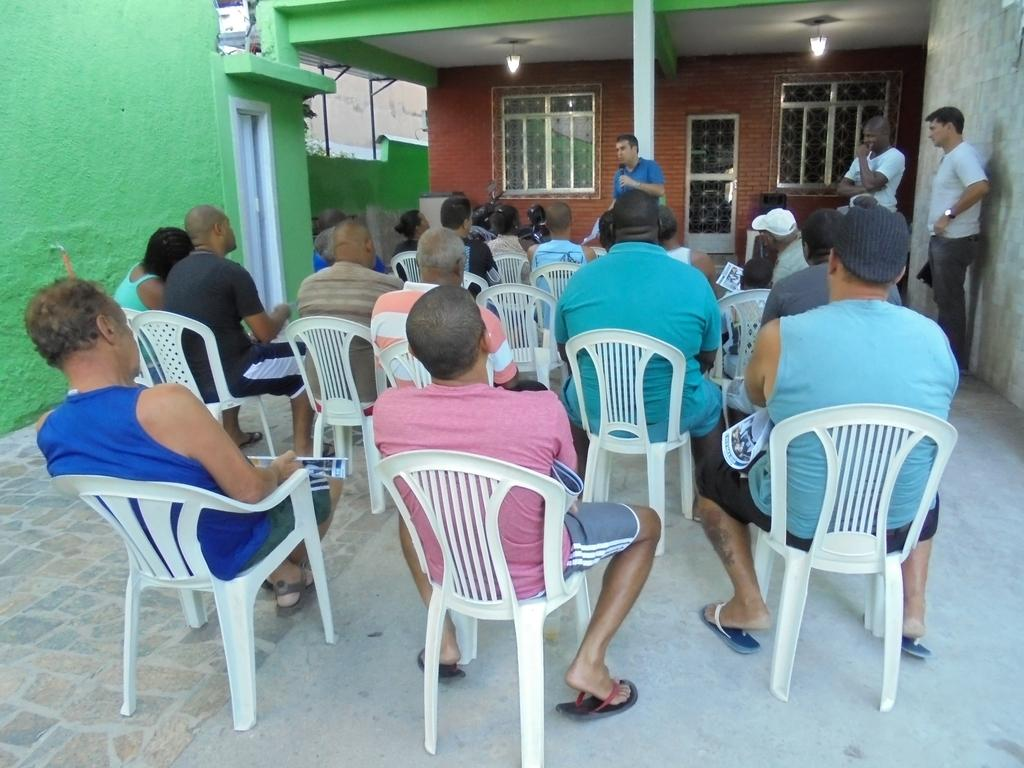What are the people in the image doing? There are many people sitting in chairs in the image, and three people are standing. Can you describe the background of the image? There is a pillar and windows visible in the background of the image. What type of cheese is being served at the table in the image? There is no table or cheese present in the image. What is the rate of the people's laughter in the image? There is no laughter or rate mentioned in the image. 